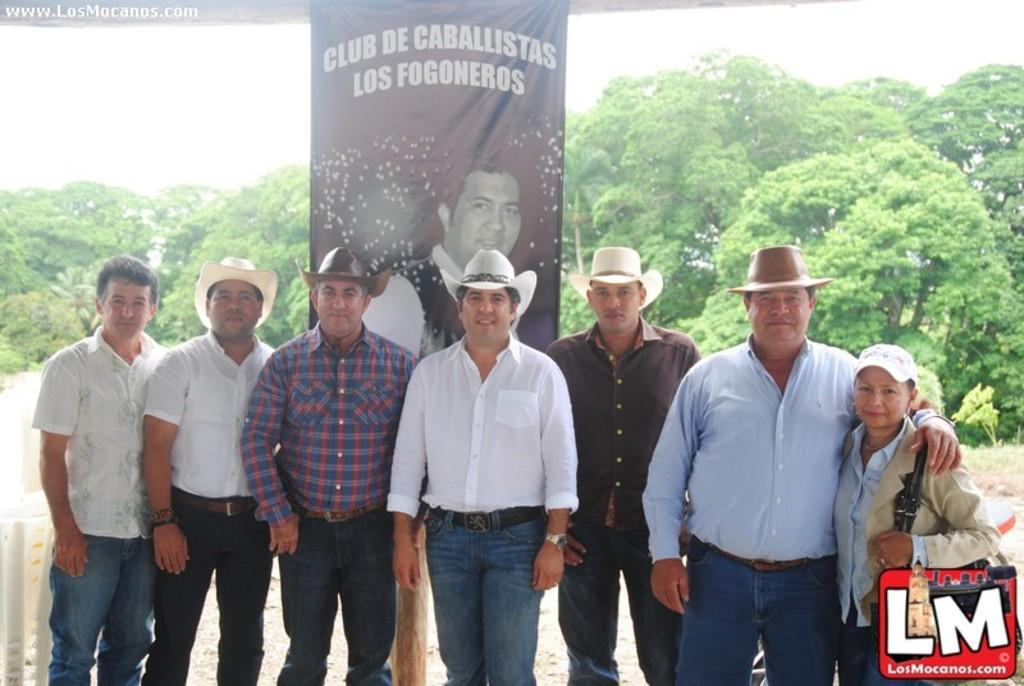What are the people in the image doing? People are standing in the image. What are the people wearing on their heads? The people are wearing hats. Can you describe the person on the right side of the image? The person on the right is wearing a bag and a cap. What is present in the image besides the people? There is a banner in the image, and trees are visible in the background. What type of veil can be seen covering the trees in the background? There is no veil present in the image, and the trees are not covered. What kind of canvas is being used to paint the banner in the image? The image does not show the process of creating the banner, so it is not possible to determine what kind of canvas was used. 